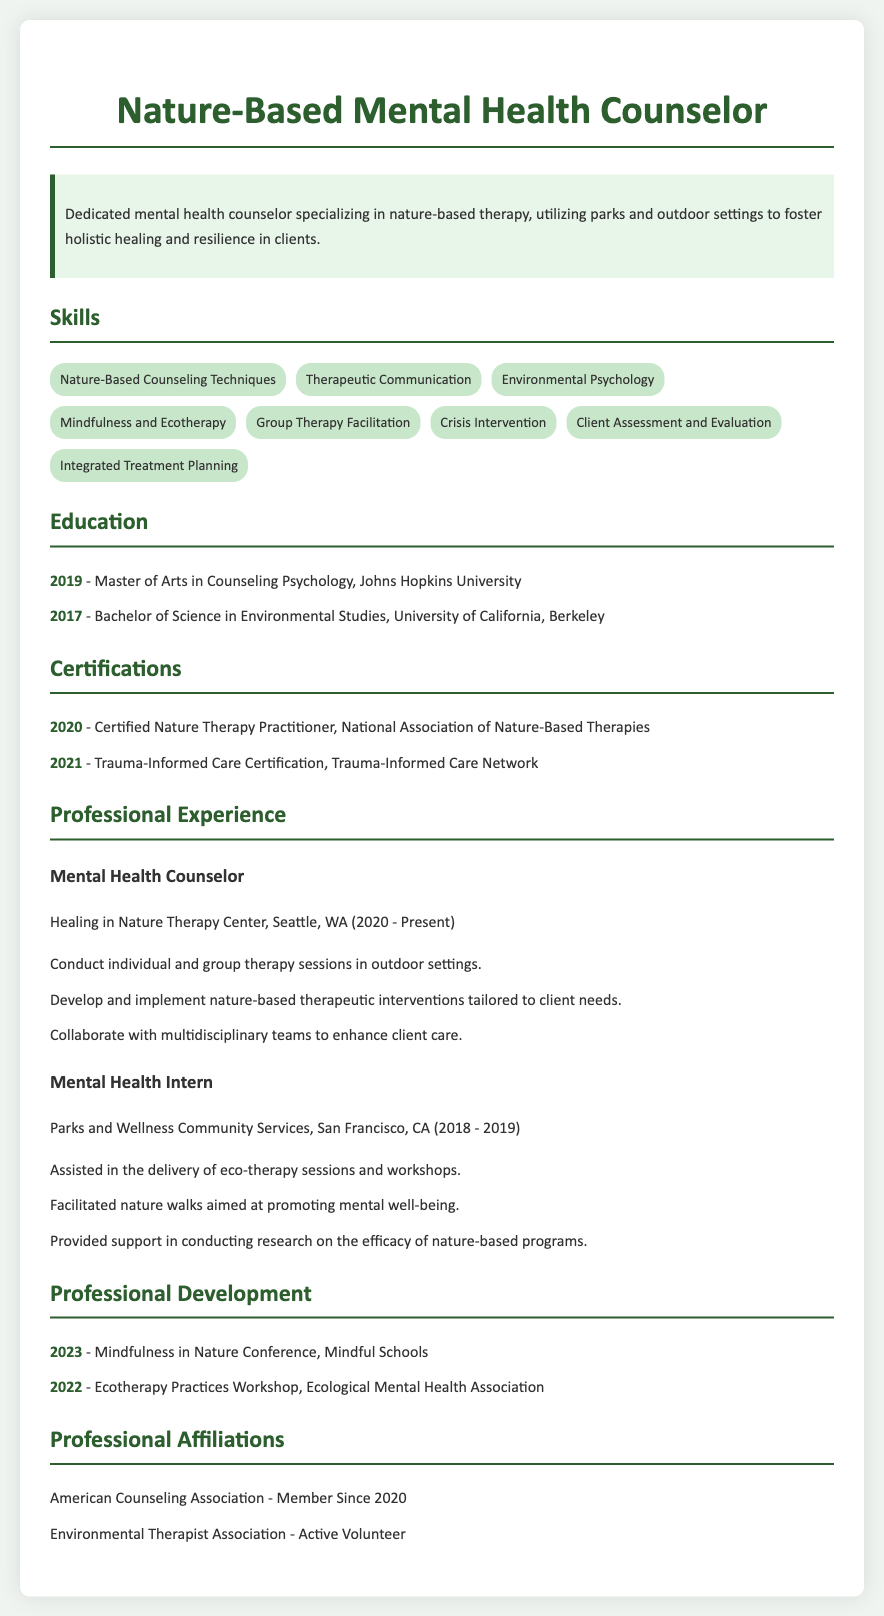What is the title of the document? The title of the document is prominently displayed at the top of the resume.
Answer: Nature-Based Mental Health Counselor What is the most recent year mentioned in Professional Development? The most recent year in the Professional Development section is the last date listed.
Answer: 2023 Which university awarded the degree in Environmental Studies? The degree in Environmental Studies is tied to a specific institution mentioned in the Education section.
Answer: University of California, Berkeley What certification was obtained in 2020? The specific certification obtained that year is listed in the Certifications section of the document.
Answer: Certified Nature Therapy Practitioner How many years of experience does the counselor have at Healing in Nature Therapy Center? The length of service at the current position is calculated from the dates provided in the experience section.
Answer: 3 years What role did the individual hold while interning in San Francisco? The title held during the internship is explicitly stated in the Professional Experience section.
Answer: Mental Health Intern What organization is affiliated with the ecotherapy workshop attended? The name of the organization hosting the workshop is listed in the Professional Development section.
Answer: Ecological Mental Health Association What skill is related to therapeutic communication? The specific skill related to therapeutic communication is included in the Skills section.
Answer: Therapeutic Communication What is the role of "American Counseling Association" in this resume? The document indicates membership in an organization, specific to professional affiliations.
Answer: Member Since 2020 